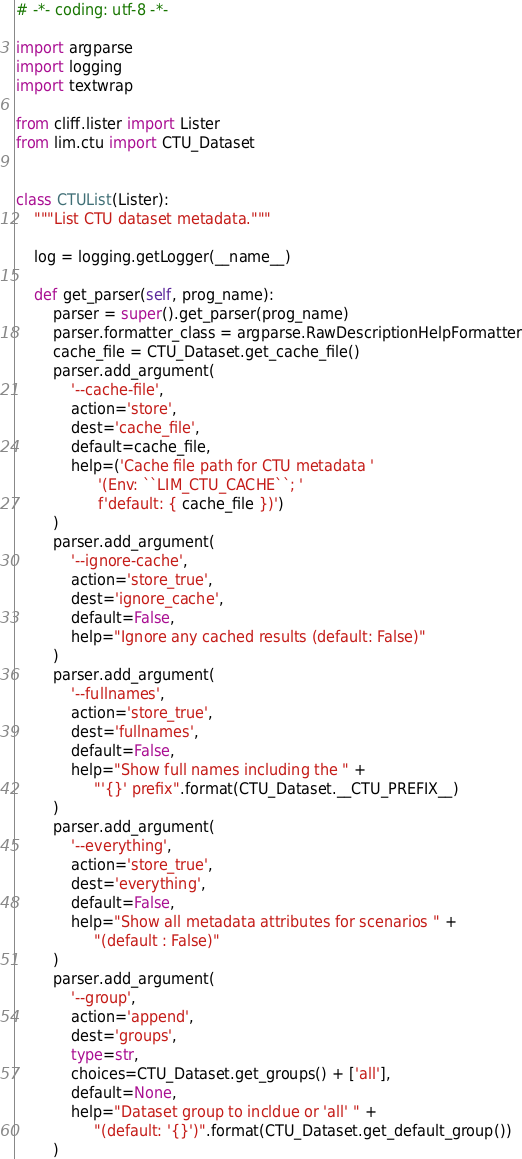<code> <loc_0><loc_0><loc_500><loc_500><_Python_># -*- coding: utf-8 -*-

import argparse
import logging
import textwrap

from cliff.lister import Lister
from lim.ctu import CTU_Dataset


class CTUList(Lister):
    """List CTU dataset metadata."""

    log = logging.getLogger(__name__)

    def get_parser(self, prog_name):
        parser = super().get_parser(prog_name)
        parser.formatter_class = argparse.RawDescriptionHelpFormatter
        cache_file = CTU_Dataset.get_cache_file()
        parser.add_argument(
            '--cache-file',
            action='store',
            dest='cache_file',
            default=cache_file,
            help=('Cache file path for CTU metadata '
                  '(Env: ``LIM_CTU_CACHE``; '
                  f'default: { cache_file })')
        )
        parser.add_argument(
            '--ignore-cache',
            action='store_true',
            dest='ignore_cache',
            default=False,
            help="Ignore any cached results (default: False)"
        )
        parser.add_argument(
            '--fullnames',
            action='store_true',
            dest='fullnames',
            default=False,
            help="Show full names including the " +
                 "'{}' prefix".format(CTU_Dataset.__CTU_PREFIX__)
        )
        parser.add_argument(
            '--everything',
            action='store_true',
            dest='everything',
            default=False,
            help="Show all metadata attributes for scenarios " +
                 "(default : False)"
        )
        parser.add_argument(
            '--group',
            action='append',
            dest='groups',
            type=str,
            choices=CTU_Dataset.get_groups() + ['all'],
            default=None,
            help="Dataset group to incldue or 'all' " +
                 "(default: '{}')".format(CTU_Dataset.get_default_group())
        )</code> 